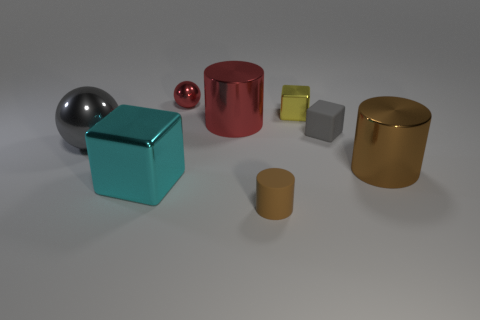Add 1 big cyan shiny blocks. How many objects exist? 9 Subtract all balls. How many objects are left? 6 Add 8 big red shiny objects. How many big red shiny objects are left? 9 Add 8 red spheres. How many red spheres exist? 9 Subtract 0 purple cylinders. How many objects are left? 8 Subtract all big cyan metallic blocks. Subtract all shiny objects. How many objects are left? 1 